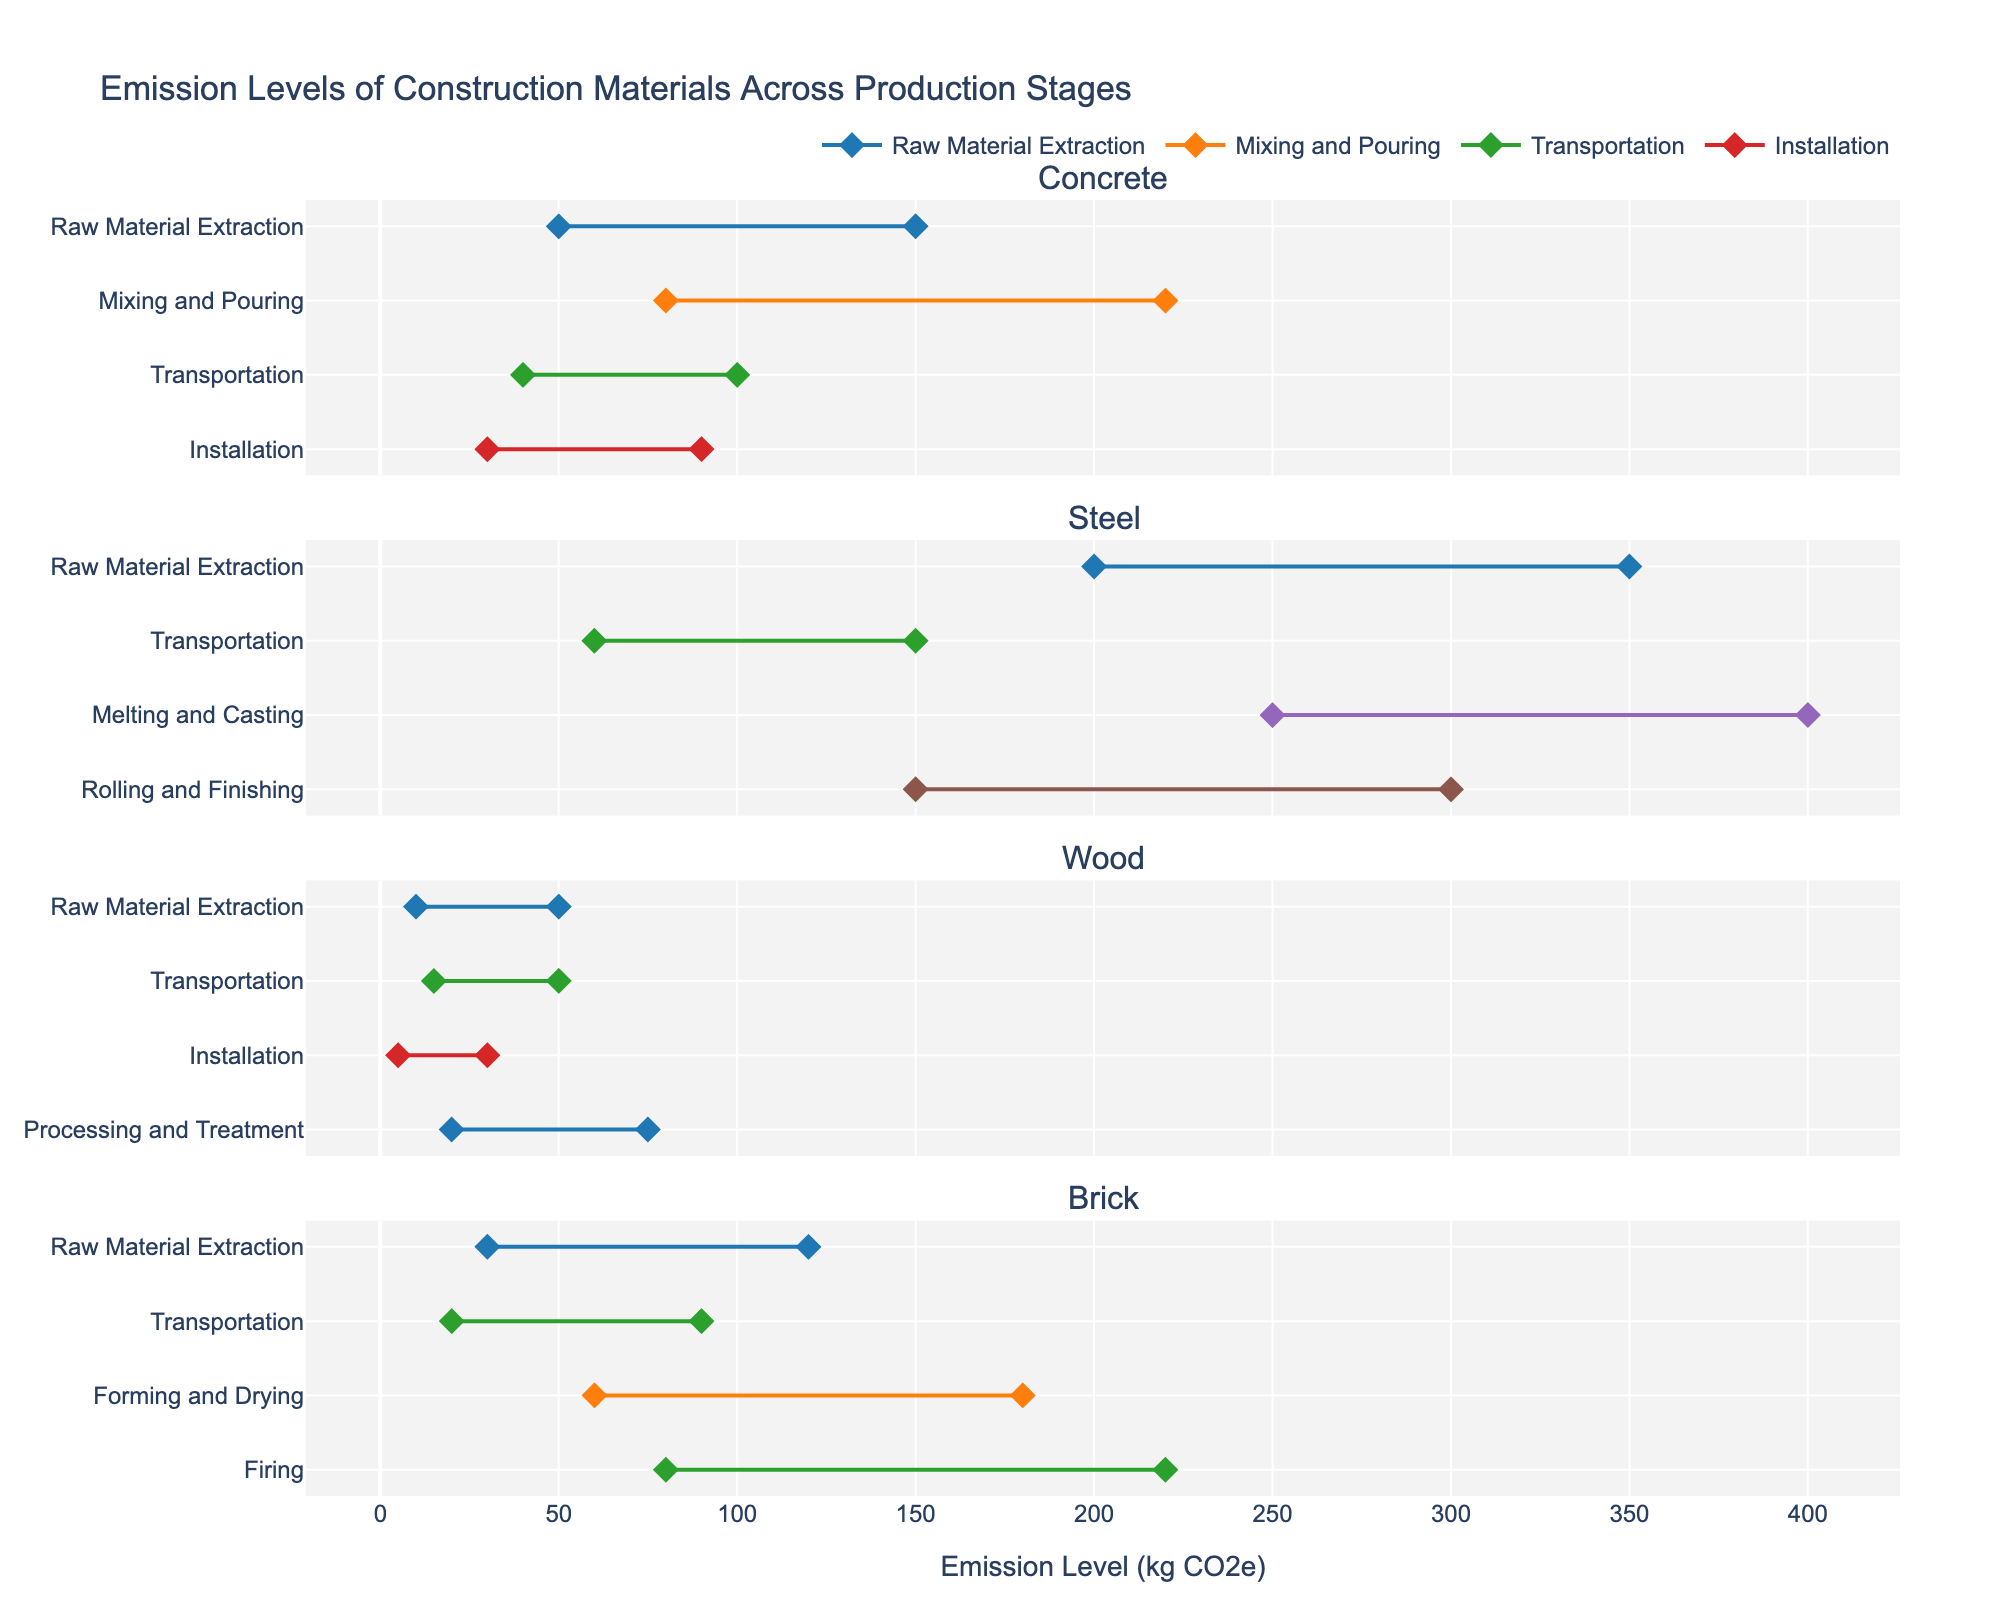What's the title of this figure? The title is typically displayed at the top of the figure. In this case, it is "Emission Levels of Construction Materials Across Production Stages" which is stated in the code.
Answer: Emission Levels of Construction Materials Across Production Stages How many materials are compared in the figure? By counting the unique material names from the data, we find the materials are Concrete, Steel, Wood, and Brick. So there are 4 materials.
Answer: 4 Which material has the highest maximum emission level in any production stage? Looking at the maximum emission levels for each material, Steel has the highest maximum emission level of 400 kg CO2e during the Melting and Casting stage.
Answer: Steel Which material and production stage has the lowest minimum emission level? We look for the lowest value in the "Min Emission Level" column. The lowest value is 5 kg CO2e, which is for Wood during the Installation stage.
Answer: Wood, Installation What's the range of emission levels for the Brick during the Firing stage? For Brick at the Firing stage, we look at the minimum and maximum emission levels which are 80 kg CO2e and 220 kg CO2e respectively. The range is the difference between the maximum and minimum values, which is 220 - 80 = 140 kg CO2e.
Answer: 140 kg CO2e Which production stage has the highest variability in emission levels for Concrete? The variability can be understood as the range between the maximum and minimum emission levels. For Concrete: 
- Raw Material Extraction: 150 - 50 = 100
- Mixing and Pouring: 220 - 80 = 140
- Transportation: 100 - 40 = 60
- Installation: 90 - 30 = 60
The highest variability is in the Mixing and Pouring stage with a range of 140 kg CO2e.
Answer: Mixing and Pouring Are the emission levels more variable in Brick or Wood's transportation stage? We compare the range of emission levels for the Transportation stage:
- Brick: 90 - 20 = 70 kg CO2e
- Wood: 50 - 15 = 35 kg CO2e
The emission levels are more variable for Brick's transportation stage.
Answer: Brick What is the average maximum emission level across all production stages for Steel? We calculate the average of maximum emission levels for Steel:
- Raw Material Extraction: 350
- Melting and Casting: 400
- Rolling and Finishing: 300
- Transportation: 150
The average is (350 + 400 + 300 + 150) / 4 = 1200 / 4 = 300 kg CO2e.
Answer: 300 kg CO2e What are the common production stages for all the materials? We identify the production stages present for each material. The common stages across all materials are Raw Material Extraction and Transportation.
- Concrete: Raw Material Extraction, Mixing and Pouring, Transportation, Installation
- Steel: Raw Material Extraction, Melting and Casting, Rolling and Finishing, Transportation
- Wood: Raw Material Extraction, Processing and Treatment, Transportation, Installation
- Brick: Raw Material Extraction, Forming and Drying, Firing, Transportation
The stages Raw Material Extraction and Transportation appear in all materials.
Answer: Raw Material Extraction, Transportation 